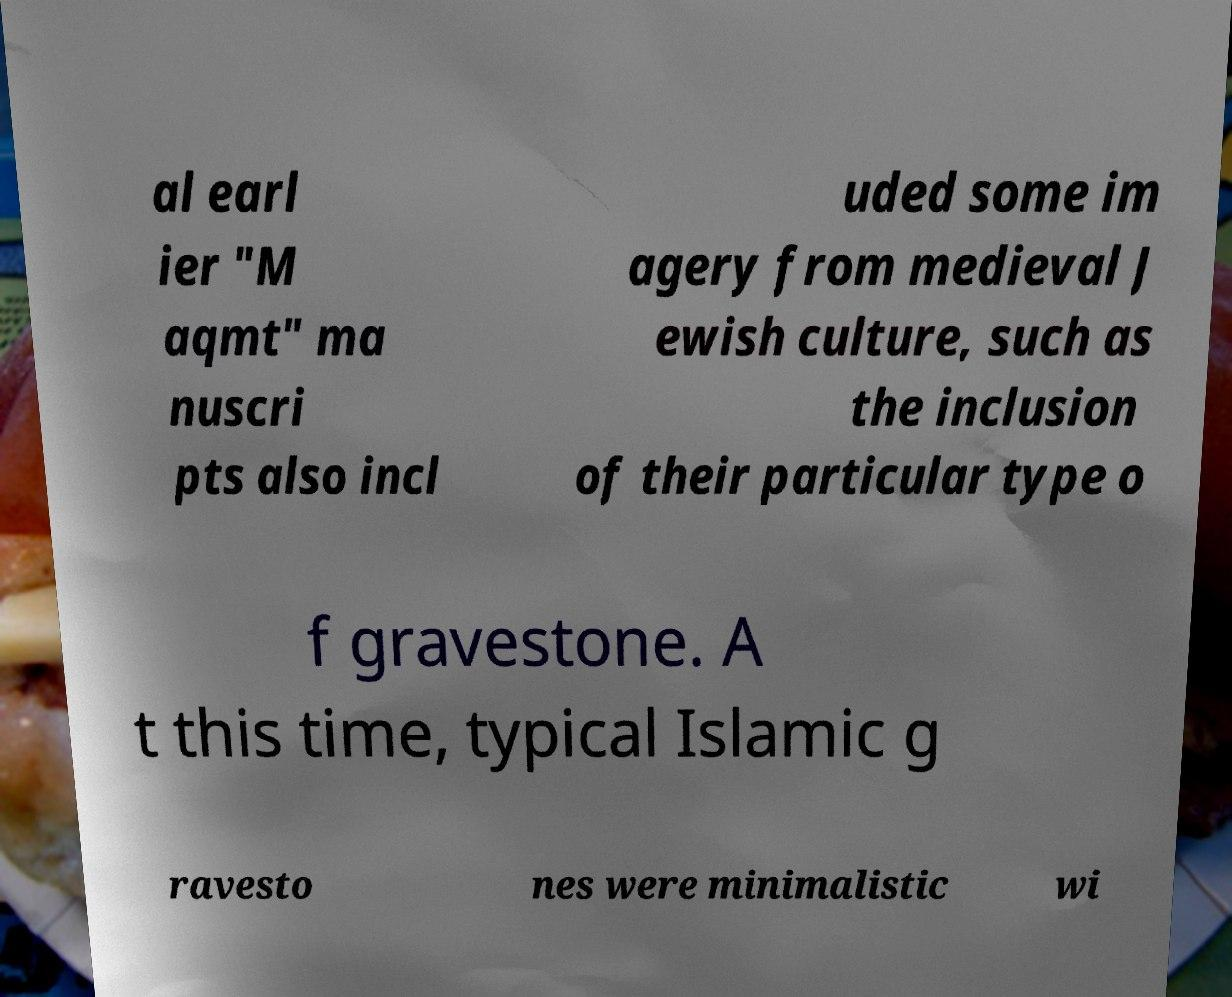Can you accurately transcribe the text from the provided image for me? al earl ier "M aqmt" ma nuscri pts also incl uded some im agery from medieval J ewish culture, such as the inclusion of their particular type o f gravestone. A t this time, typical Islamic g ravesto nes were minimalistic wi 